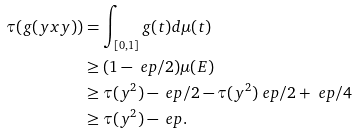Convert formula to latex. <formula><loc_0><loc_0><loc_500><loc_500>\tau ( g ( y x y ) ) & = \int _ { [ 0 , 1 ] } g ( t ) d \mu ( t ) \\ & \geq ( 1 - \ e p / 2 ) \mu ( E ) \\ & \geq \tau ( y ^ { 2 } ) - \ e p / 2 - \tau ( y ^ { 2 } ) \ e p / 2 + \ e p / 4 \\ & \geq \tau ( y ^ { 2 } ) - \ e p .</formula> 